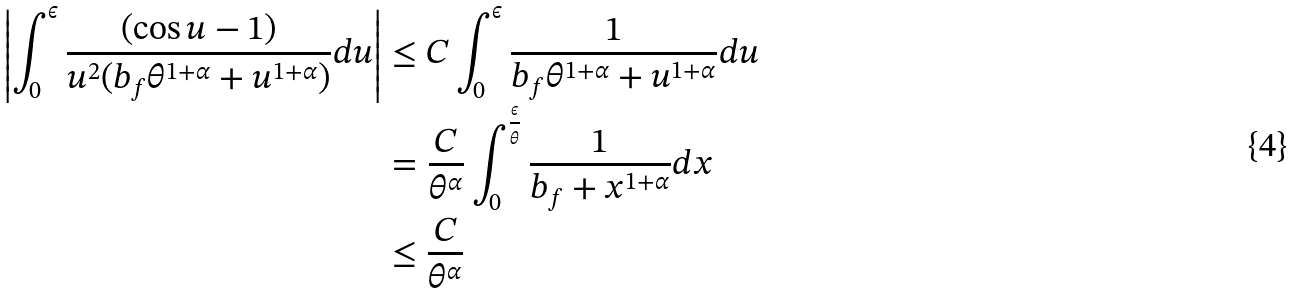<formula> <loc_0><loc_0><loc_500><loc_500>\left | \int _ { 0 } ^ { \epsilon } \frac { ( \cos u - 1 ) } { u ^ { 2 } ( b _ { f } \theta ^ { 1 + \alpha } + u ^ { 1 + \alpha } ) } d u \right | & \leq C \int _ { 0 } ^ { \epsilon } \frac { 1 } { b _ { f } \theta ^ { 1 + \alpha } + u ^ { 1 + \alpha } } d u \\ & = \frac { C } { \theta ^ { \alpha } } \int _ { 0 } ^ { \frac { \epsilon } { \theta } } \frac { 1 } { b _ { f } + x ^ { 1 + \alpha } } d x \\ & \leq \frac { C } { \theta ^ { \alpha } }</formula> 